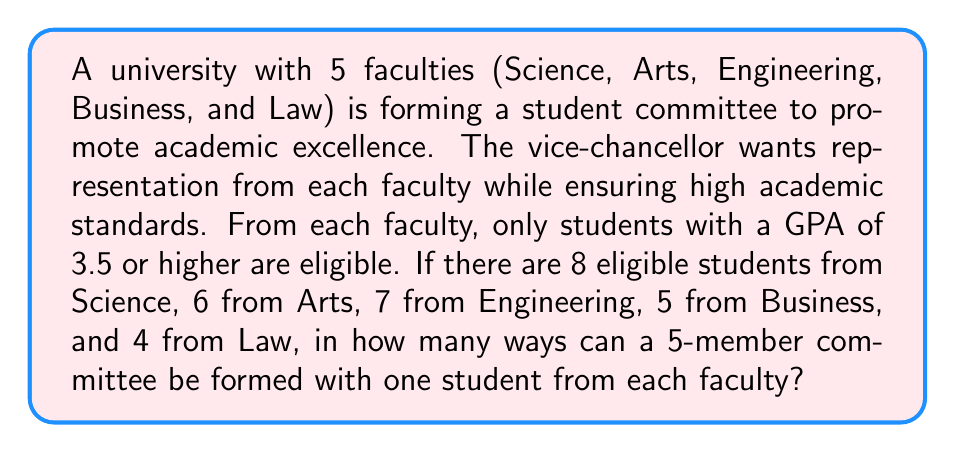Can you answer this question? Let's approach this step-by-step:

1) We need to select one student from each faculty. This is a case of independent selections.

2) For each faculty, we have:
   - Science: 8 eligible students
   - Arts: 6 eligible students
   - Engineering: 7 eligible students
   - Business: 5 eligible students
   - Law: 4 eligible students

3) According to the Multiplication Principle, when we have independent selections, we multiply the number of ways for each selection.

4) Therefore, the total number of ways to form the committee is:

   $$8 \times 6 \times 7 \times 5 \times 4$$

5) Calculating this:
   $$8 \times 6 \times 7 \times 5 \times 4 = 6720$$

Thus, there are 6720 ways to form the committee.
Answer: 6720 